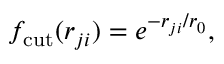Convert formula to latex. <formula><loc_0><loc_0><loc_500><loc_500>f _ { c u t } ( r _ { j i } ) = e ^ { - r _ { j i } / r _ { 0 } } ,</formula> 